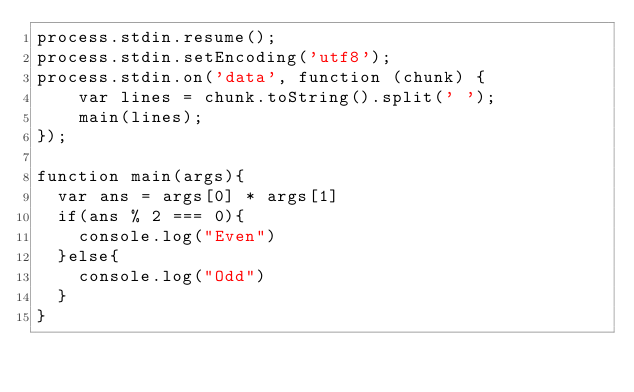<code> <loc_0><loc_0><loc_500><loc_500><_JavaScript_>process.stdin.resume();
process.stdin.setEncoding('utf8');
process.stdin.on('data', function (chunk) {
    var lines = chunk.toString().split(' ');
    main(lines);
});
 
function main(args){
  var ans = args[0] * args[1]
  if(ans % 2 === 0){
    console.log("Even")
  }else{
    console.log("Odd")
  }
}</code> 